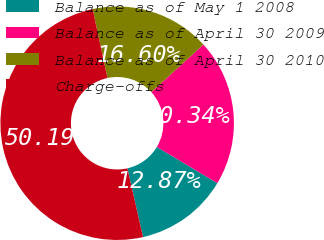<chart> <loc_0><loc_0><loc_500><loc_500><pie_chart><fcel>Balance as of May 1 2008<fcel>Balance as of April 30 2009<fcel>Balance as of April 30 2010<fcel>Charge-offs<nl><fcel>12.87%<fcel>20.34%<fcel>16.6%<fcel>50.19%<nl></chart> 